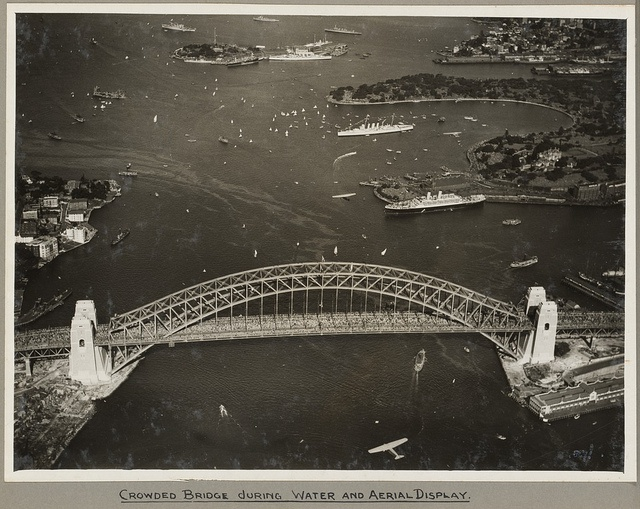Describe the objects in this image and their specific colors. I can see boat in darkgray, black, and gray tones, boat in darkgray, black, gray, and lightgray tones, boat in darkgray, lightgray, and gray tones, boat in darkgray, gray, and lightgray tones, and airplane in darkgray, black, and gray tones in this image. 